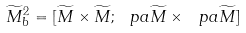<formula> <loc_0><loc_0><loc_500><loc_500>\widetilde { M } ^ { 2 } _ { b } = [ \widetilde { M } \times \widetilde { M } ; \ p a \widetilde { M } \times \ p a \widetilde { M } ]</formula> 